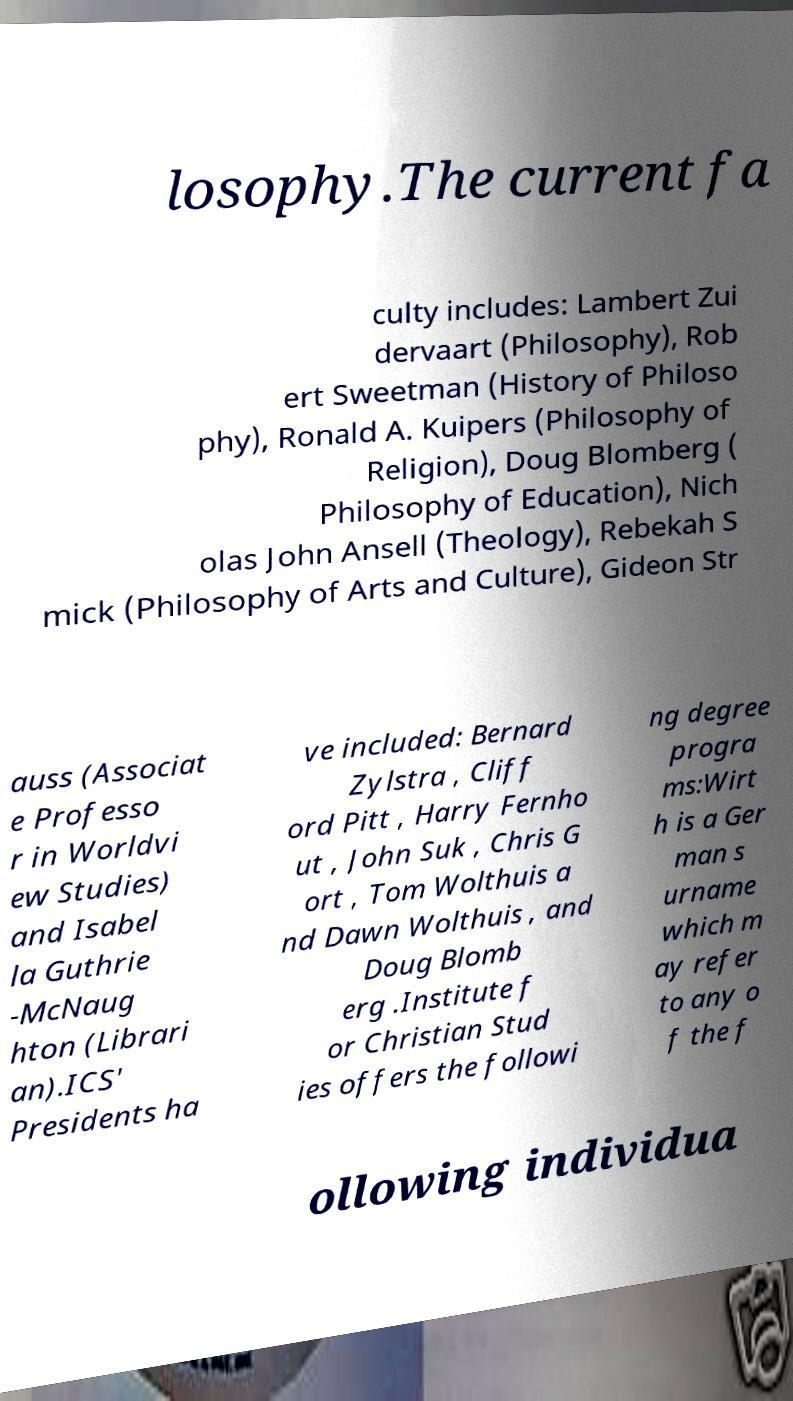Could you assist in decoding the text presented in this image and type it out clearly? losophy.The current fa culty includes: Lambert Zui dervaart (Philosophy), Rob ert Sweetman (History of Philoso phy), Ronald A. Kuipers (Philosophy of Religion), Doug Blomberg ( Philosophy of Education), Nich olas John Ansell (Theology), Rebekah S mick (Philosophy of Arts and Culture), Gideon Str auss (Associat e Professo r in Worldvi ew Studies) and Isabel la Guthrie -McNaug hton (Librari an).ICS' Presidents ha ve included: Bernard Zylstra , Cliff ord Pitt , Harry Fernho ut , John Suk , Chris G ort , Tom Wolthuis a nd Dawn Wolthuis , and Doug Blomb erg .Institute f or Christian Stud ies offers the followi ng degree progra ms:Wirt h is a Ger man s urname which m ay refer to any o f the f ollowing individua 